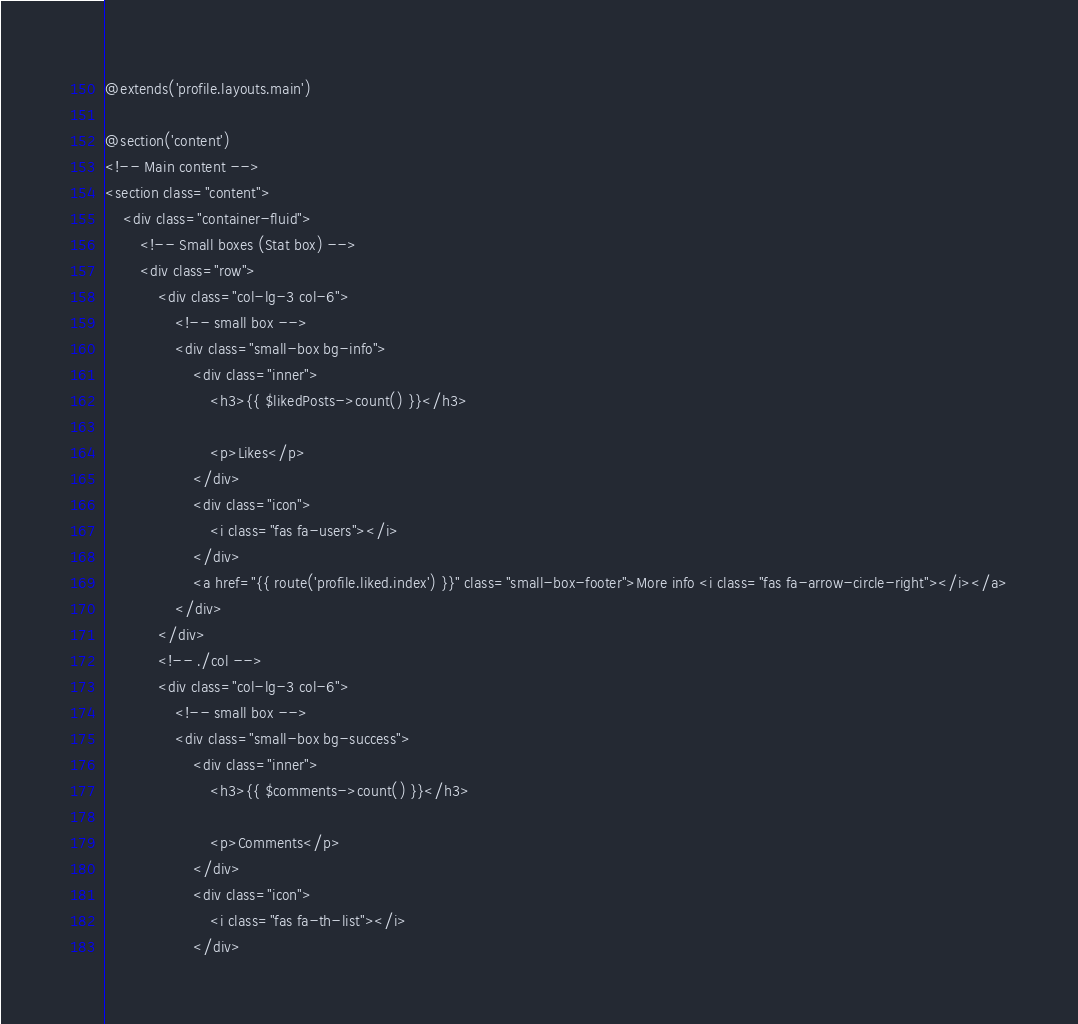<code> <loc_0><loc_0><loc_500><loc_500><_PHP_>@extends('profile.layouts.main')

@section('content')
<!-- Main content -->
<section class="content">
    <div class="container-fluid">
        <!-- Small boxes (Stat box) -->
        <div class="row">
            <div class="col-lg-3 col-6">
                <!-- small box -->
                <div class="small-box bg-info">
                    <div class="inner">
                        <h3>{{ $likedPosts->count() }}</h3>

                        <p>Likes</p>
                    </div>
                    <div class="icon">
                        <i class="fas fa-users"></i>
                    </div>
                    <a href="{{ route('profile.liked.index') }}" class="small-box-footer">More info <i class="fas fa-arrow-circle-right"></i></a>
                </div>
            </div>
            <!-- ./col -->
            <div class="col-lg-3 col-6">
                <!-- small box -->
                <div class="small-box bg-success">
                    <div class="inner">
                        <h3>{{ $comments->count() }}</h3>

                        <p>Comments</p>
                    </div>
                    <div class="icon">
                        <i class="fas fa-th-list"></i>
                    </div></code> 